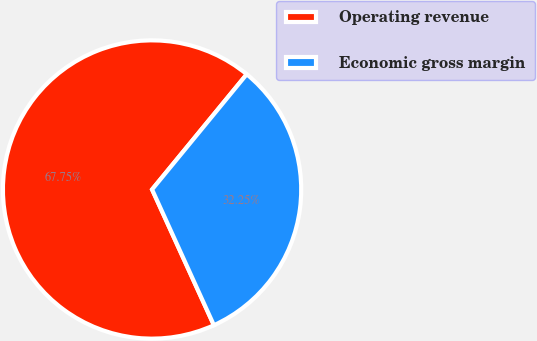Convert chart. <chart><loc_0><loc_0><loc_500><loc_500><pie_chart><fcel>Operating revenue<fcel>Economic gross margin<nl><fcel>67.75%<fcel>32.25%<nl></chart> 